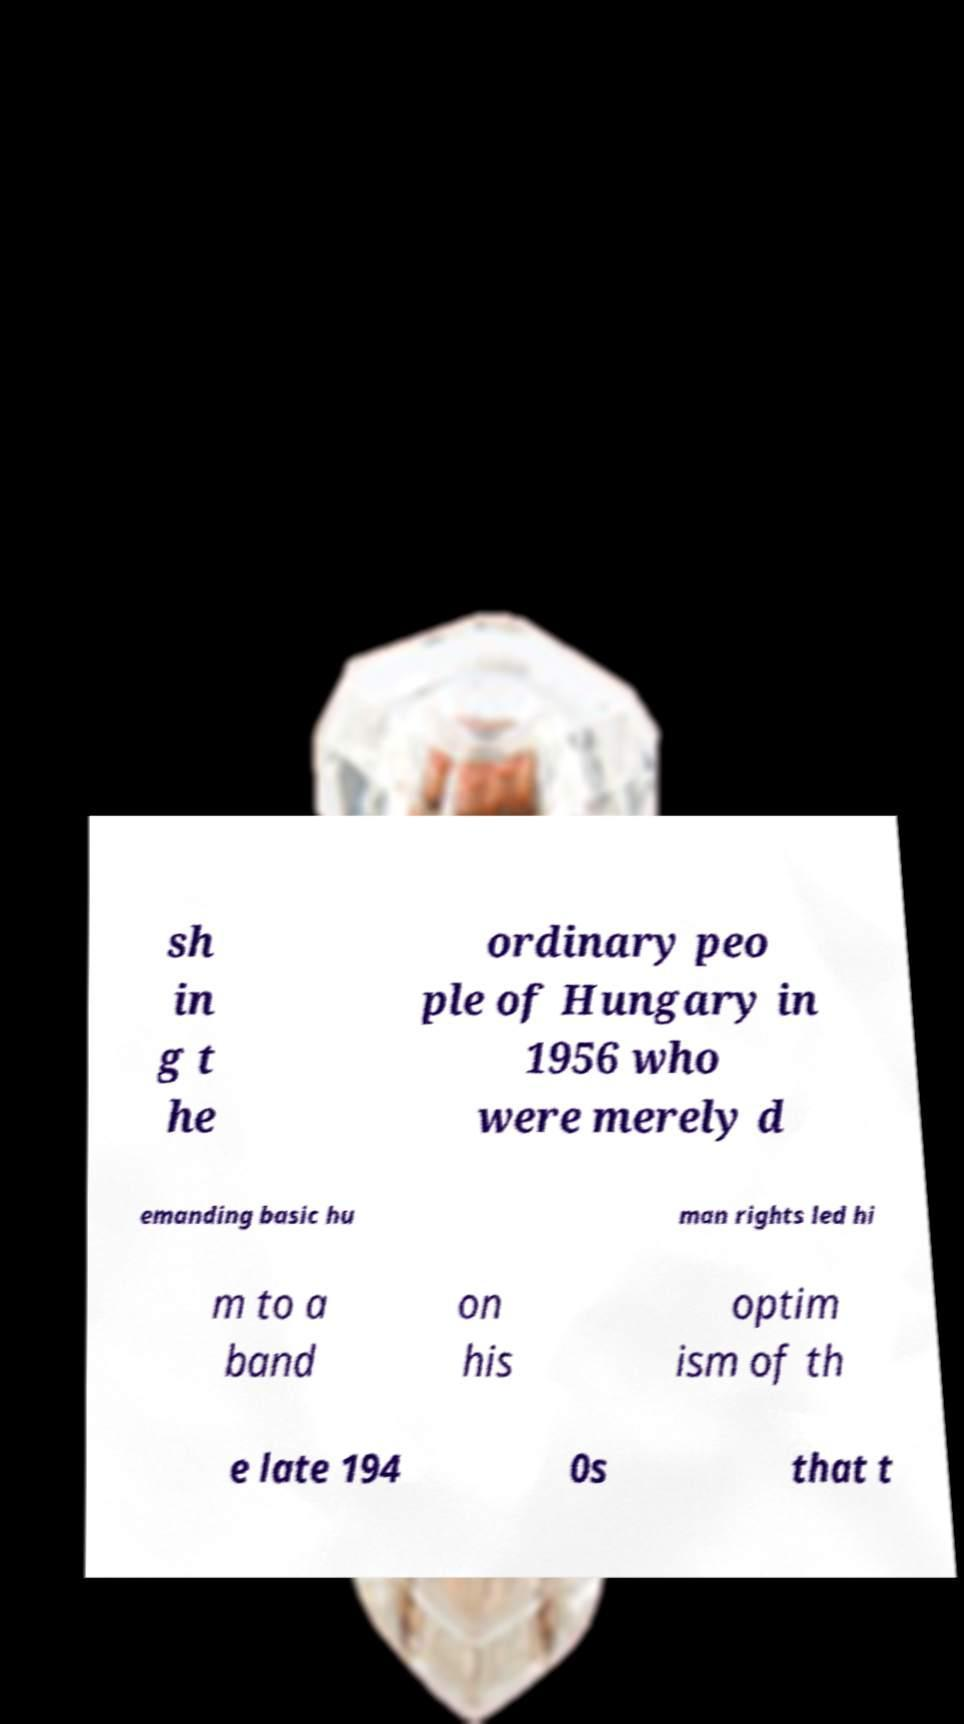Please identify and transcribe the text found in this image. sh in g t he ordinary peo ple of Hungary in 1956 who were merely d emanding basic hu man rights led hi m to a band on his optim ism of th e late 194 0s that t 